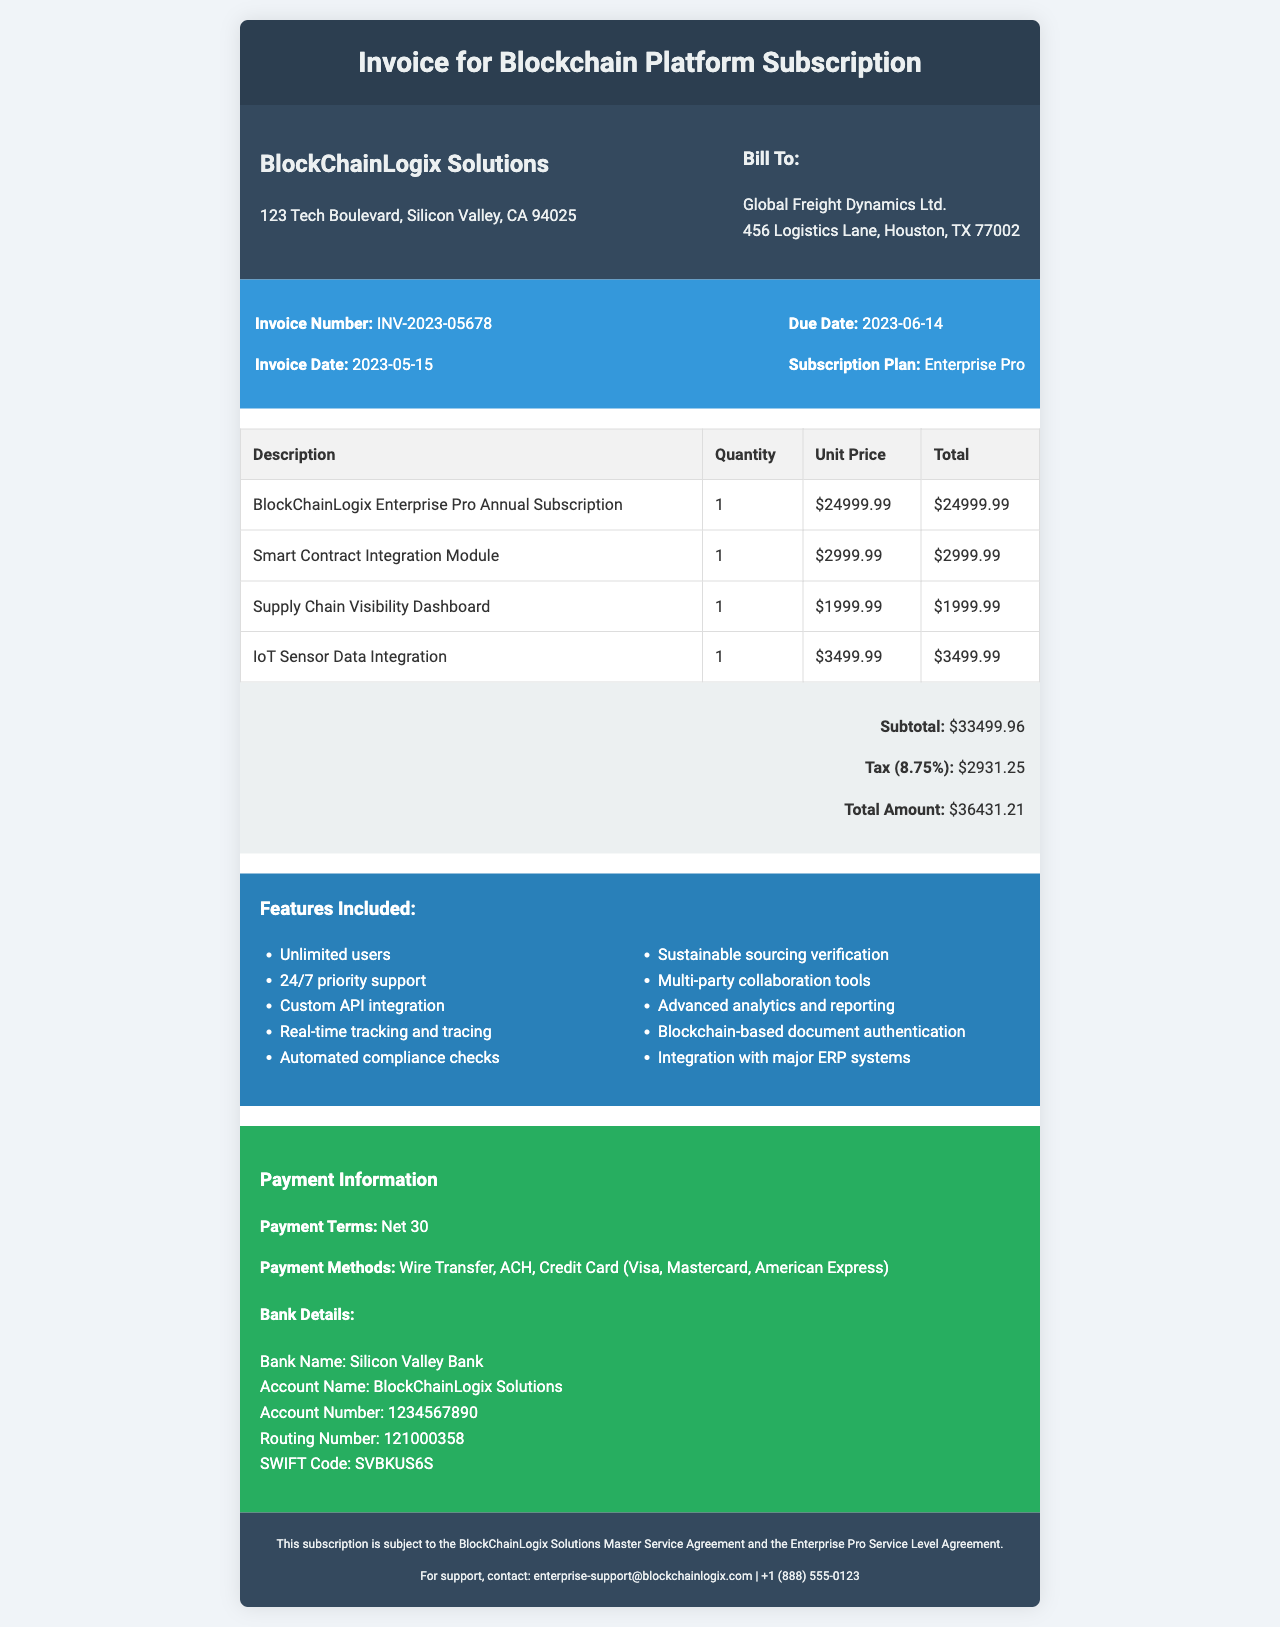What is the invoice number? The invoice number is listed clearly at the top of the document for reference.
Answer: INV-2023-05678 What is the total amount due? The total amount due is provided at the end of the invoice and includes all relevant charges.
Answer: $36431.21 Who is the customer? The name of the customer can be found in the "Bill To" section of the invoice, detailing the recipient of the services.
Answer: Global Freight Dynamics Ltd What features are included in the subscription? The features included are listed in a specific section of the document, showcasing what the customer receives.
Answer: Unlimited users, 24/7 priority support, Custom API integration, Real-time tracking and tracing, Automated compliance checks, Sustainable sourcing verification, Multi-party collaboration tools, Advanced analytics and reporting, Blockchain-based document authentication, Integration with major ERP systems What is the subscription period? The subscription period indicates the duration for which the services are provided and is mentioned in the invoice details.
Answer: May 15, 2023 - May 14, 2024 What is the payment term? The payment term outlines the timeline for payment due from the customer and is specified in a dedicated section.
Answer: Net 30 How much tax is applied to the invoice? The tax amount is shown as a specific calculation based on the subtotal in the invoice.
Answer: $2931.25 What methods of payment are accepted? The invoice states the accepted payment methods for convenience and clarity for the customer’s payment options.
Answer: Wire Transfer, ACH, Credit Card (Visa, Mastercard, American Express) 